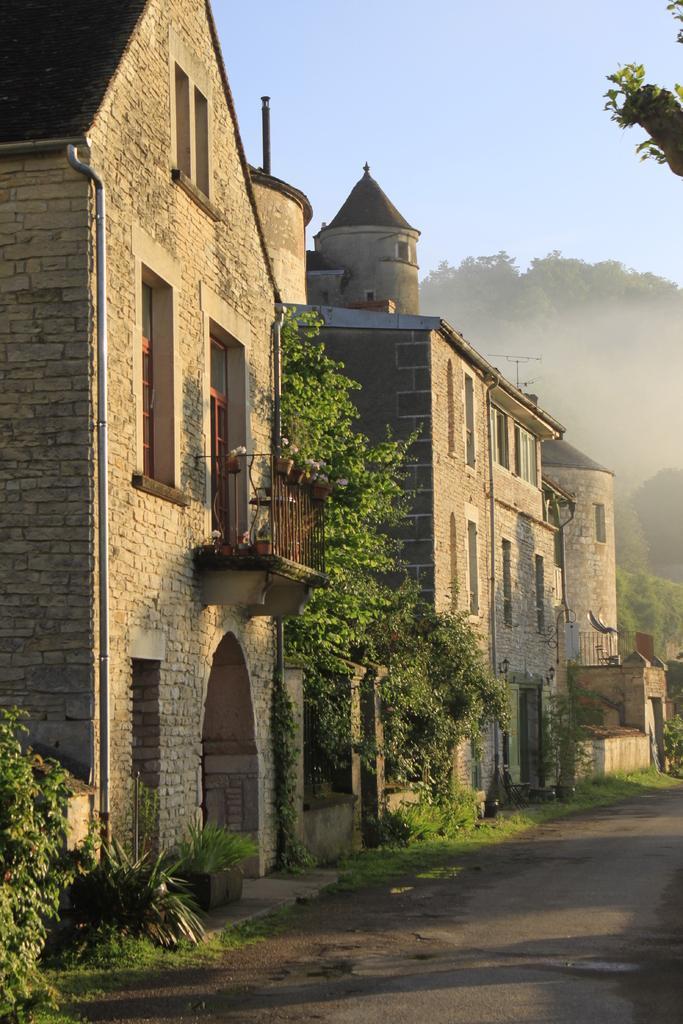In one or two sentences, can you explain what this image depicts? In this image in the center there are some buildings, trees and some plants. At the bottom there is a walkway and in the background there are trees, at the top there is sky. 